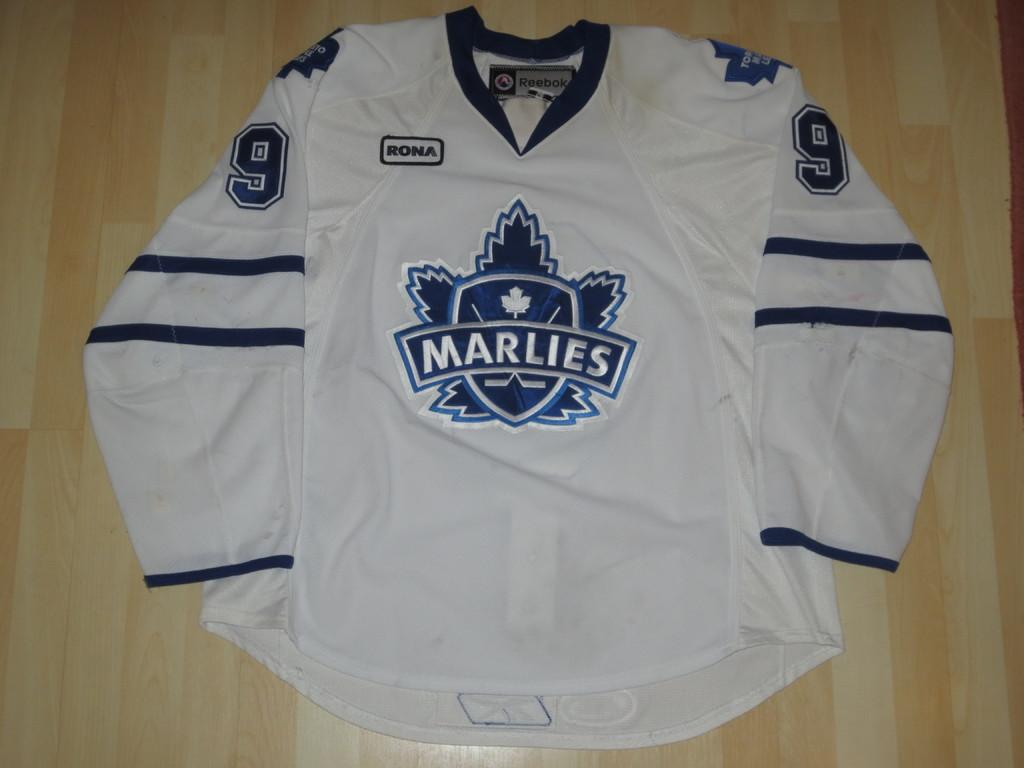Provide a one-sentence caption for the provided image. white and blue #9 jersey for the marlies on wooden surface. 